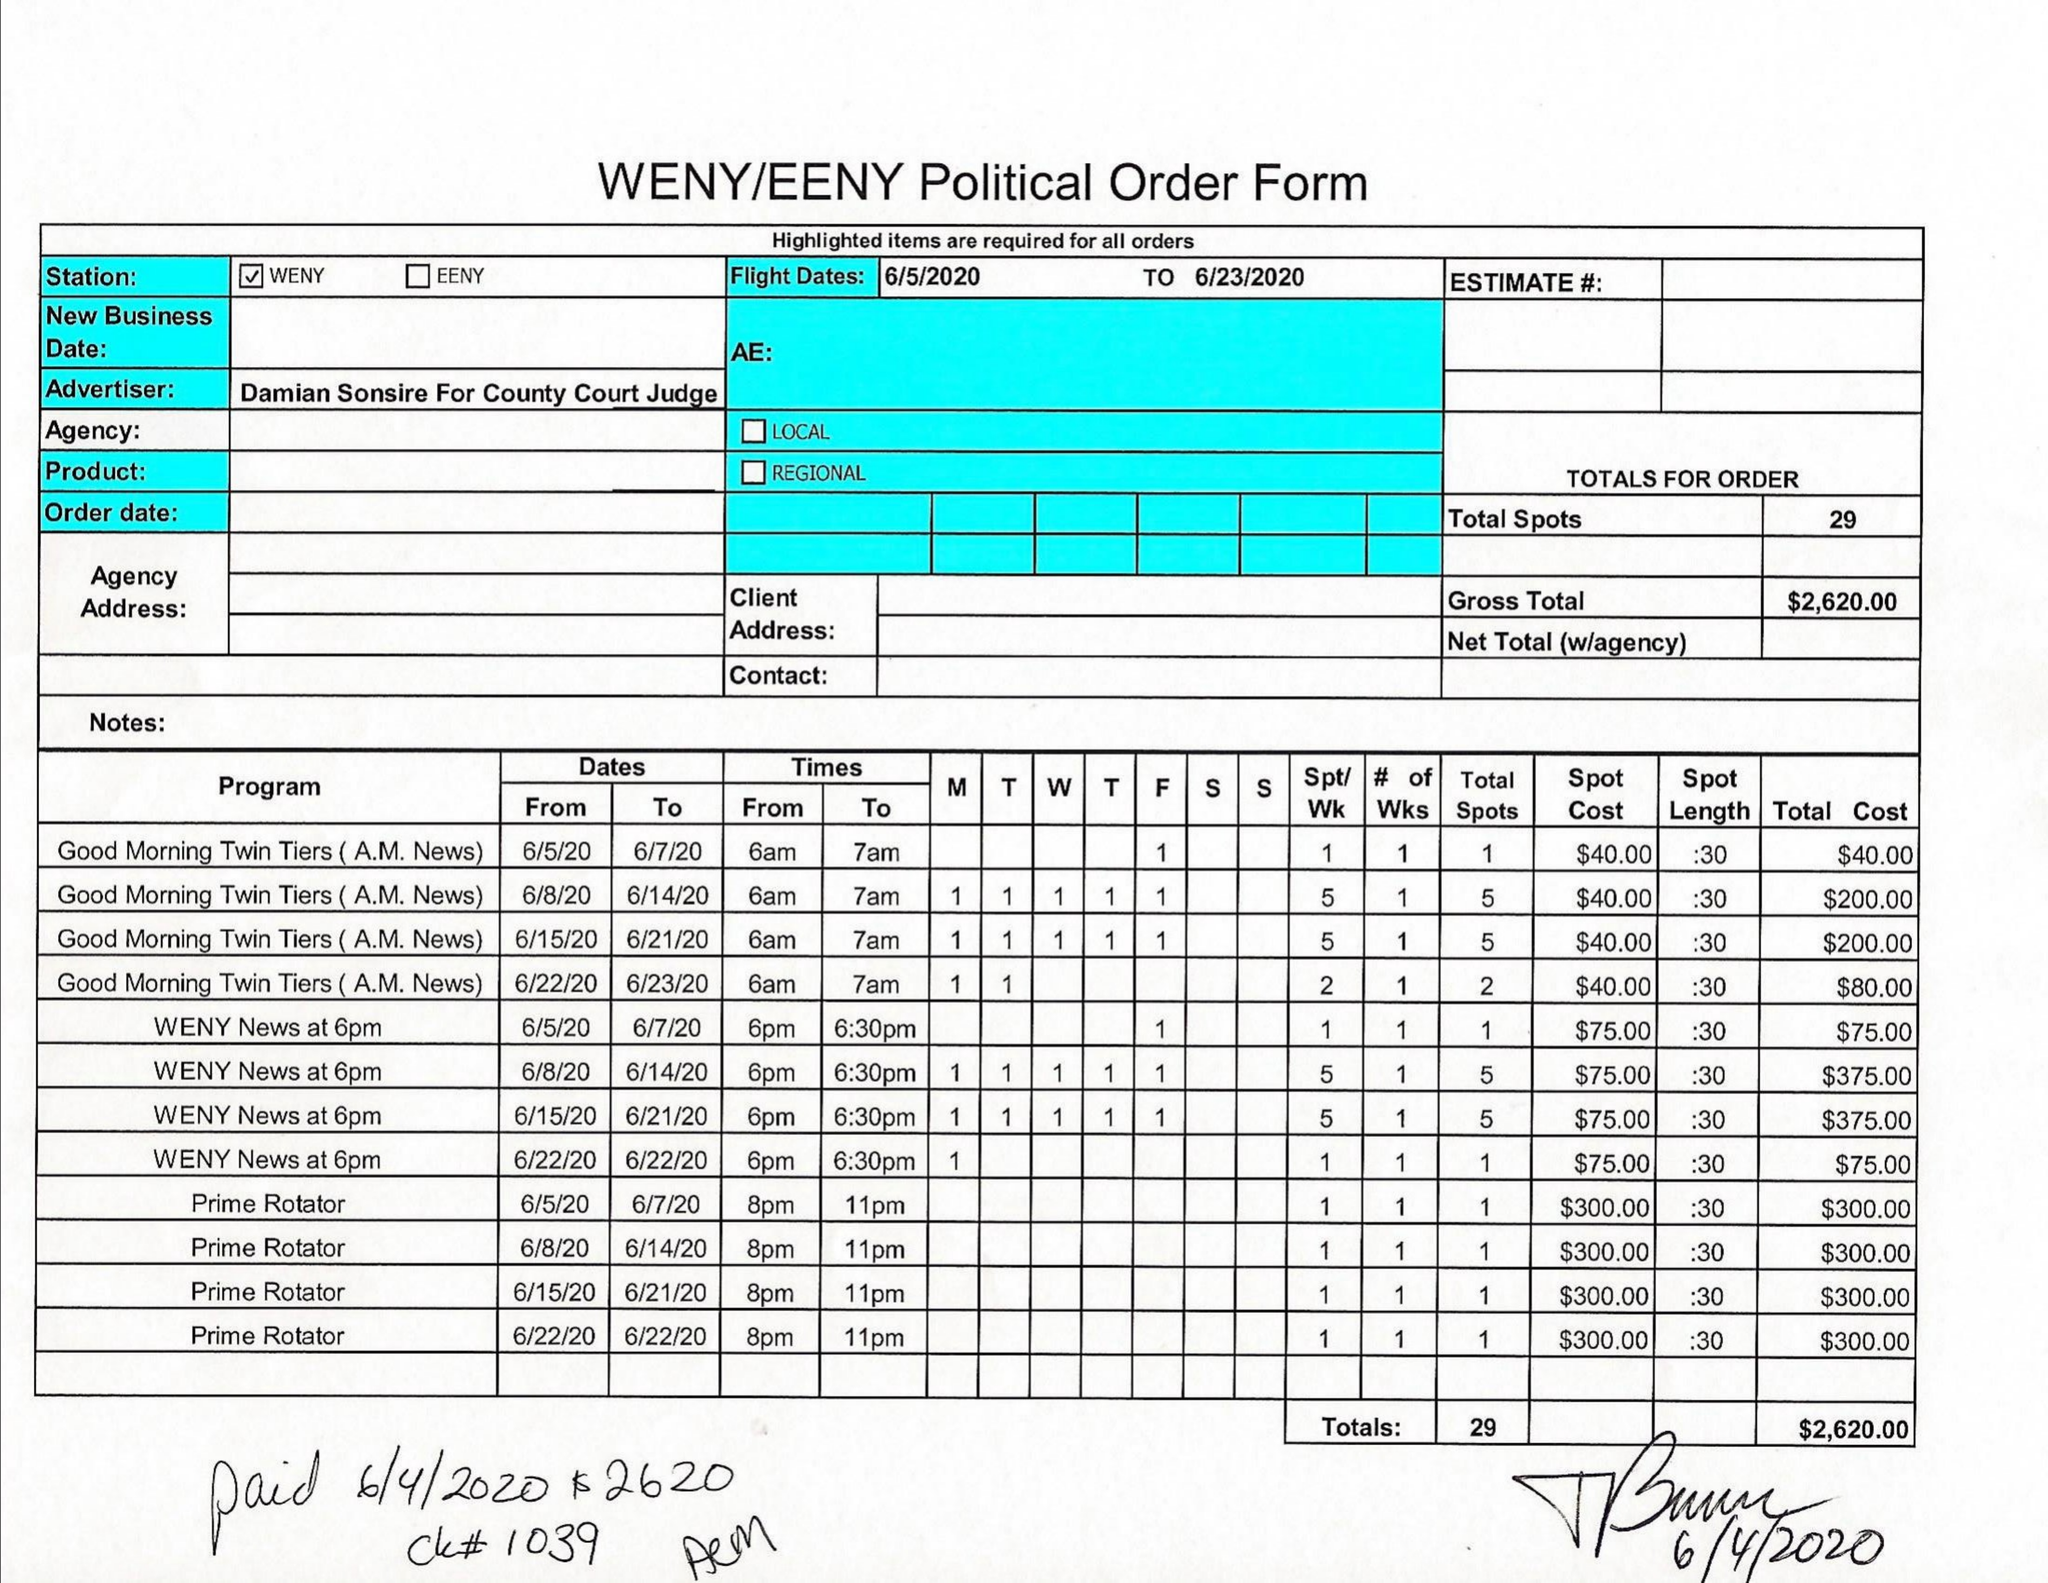What is the value for the advertiser?
Answer the question using a single word or phrase. DAMIAN SONSIRE FOR COUNTY COURT JUDGE 